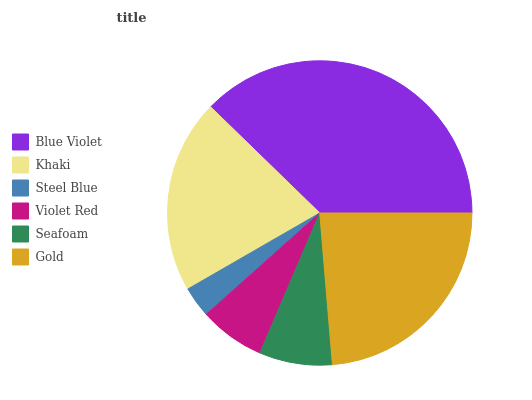Is Steel Blue the minimum?
Answer yes or no. Yes. Is Blue Violet the maximum?
Answer yes or no. Yes. Is Khaki the minimum?
Answer yes or no. No. Is Khaki the maximum?
Answer yes or no. No. Is Blue Violet greater than Khaki?
Answer yes or no. Yes. Is Khaki less than Blue Violet?
Answer yes or no. Yes. Is Khaki greater than Blue Violet?
Answer yes or no. No. Is Blue Violet less than Khaki?
Answer yes or no. No. Is Khaki the high median?
Answer yes or no. Yes. Is Seafoam the low median?
Answer yes or no. Yes. Is Seafoam the high median?
Answer yes or no. No. Is Steel Blue the low median?
Answer yes or no. No. 